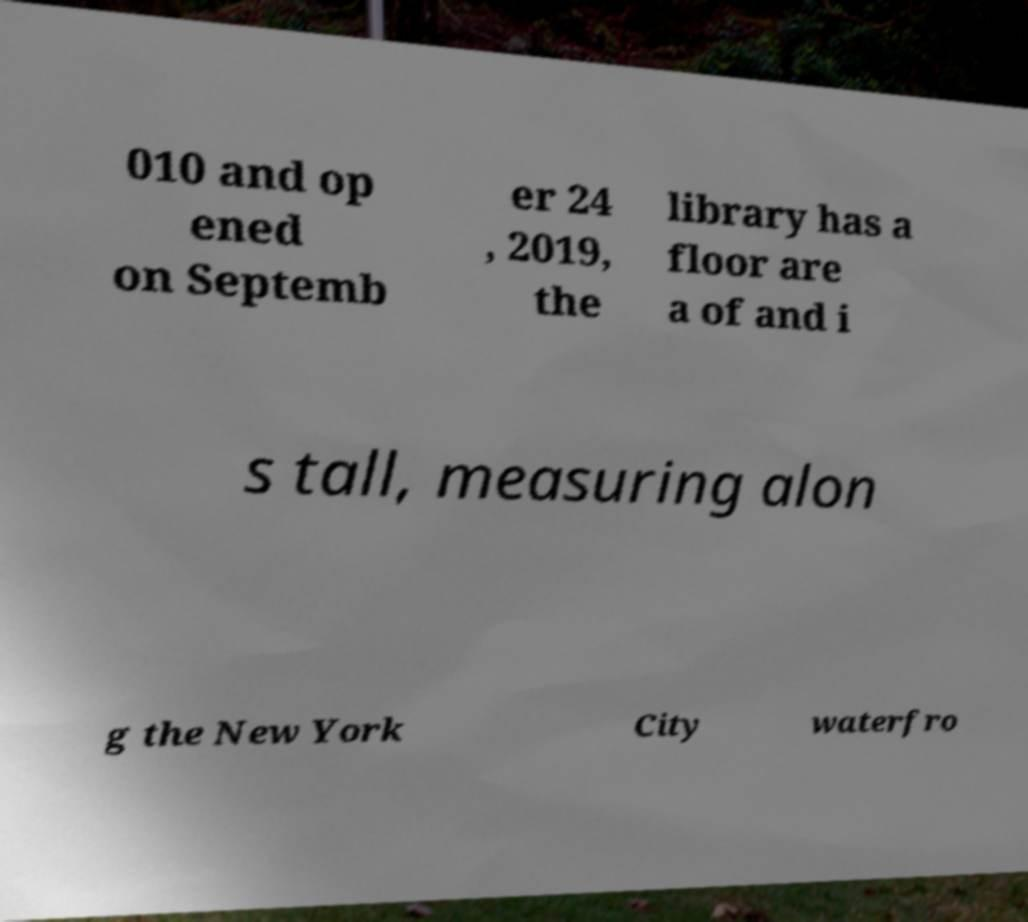For documentation purposes, I need the text within this image transcribed. Could you provide that? 010 and op ened on Septemb er 24 , 2019, the library has a floor are a of and i s tall, measuring alon g the New York City waterfro 